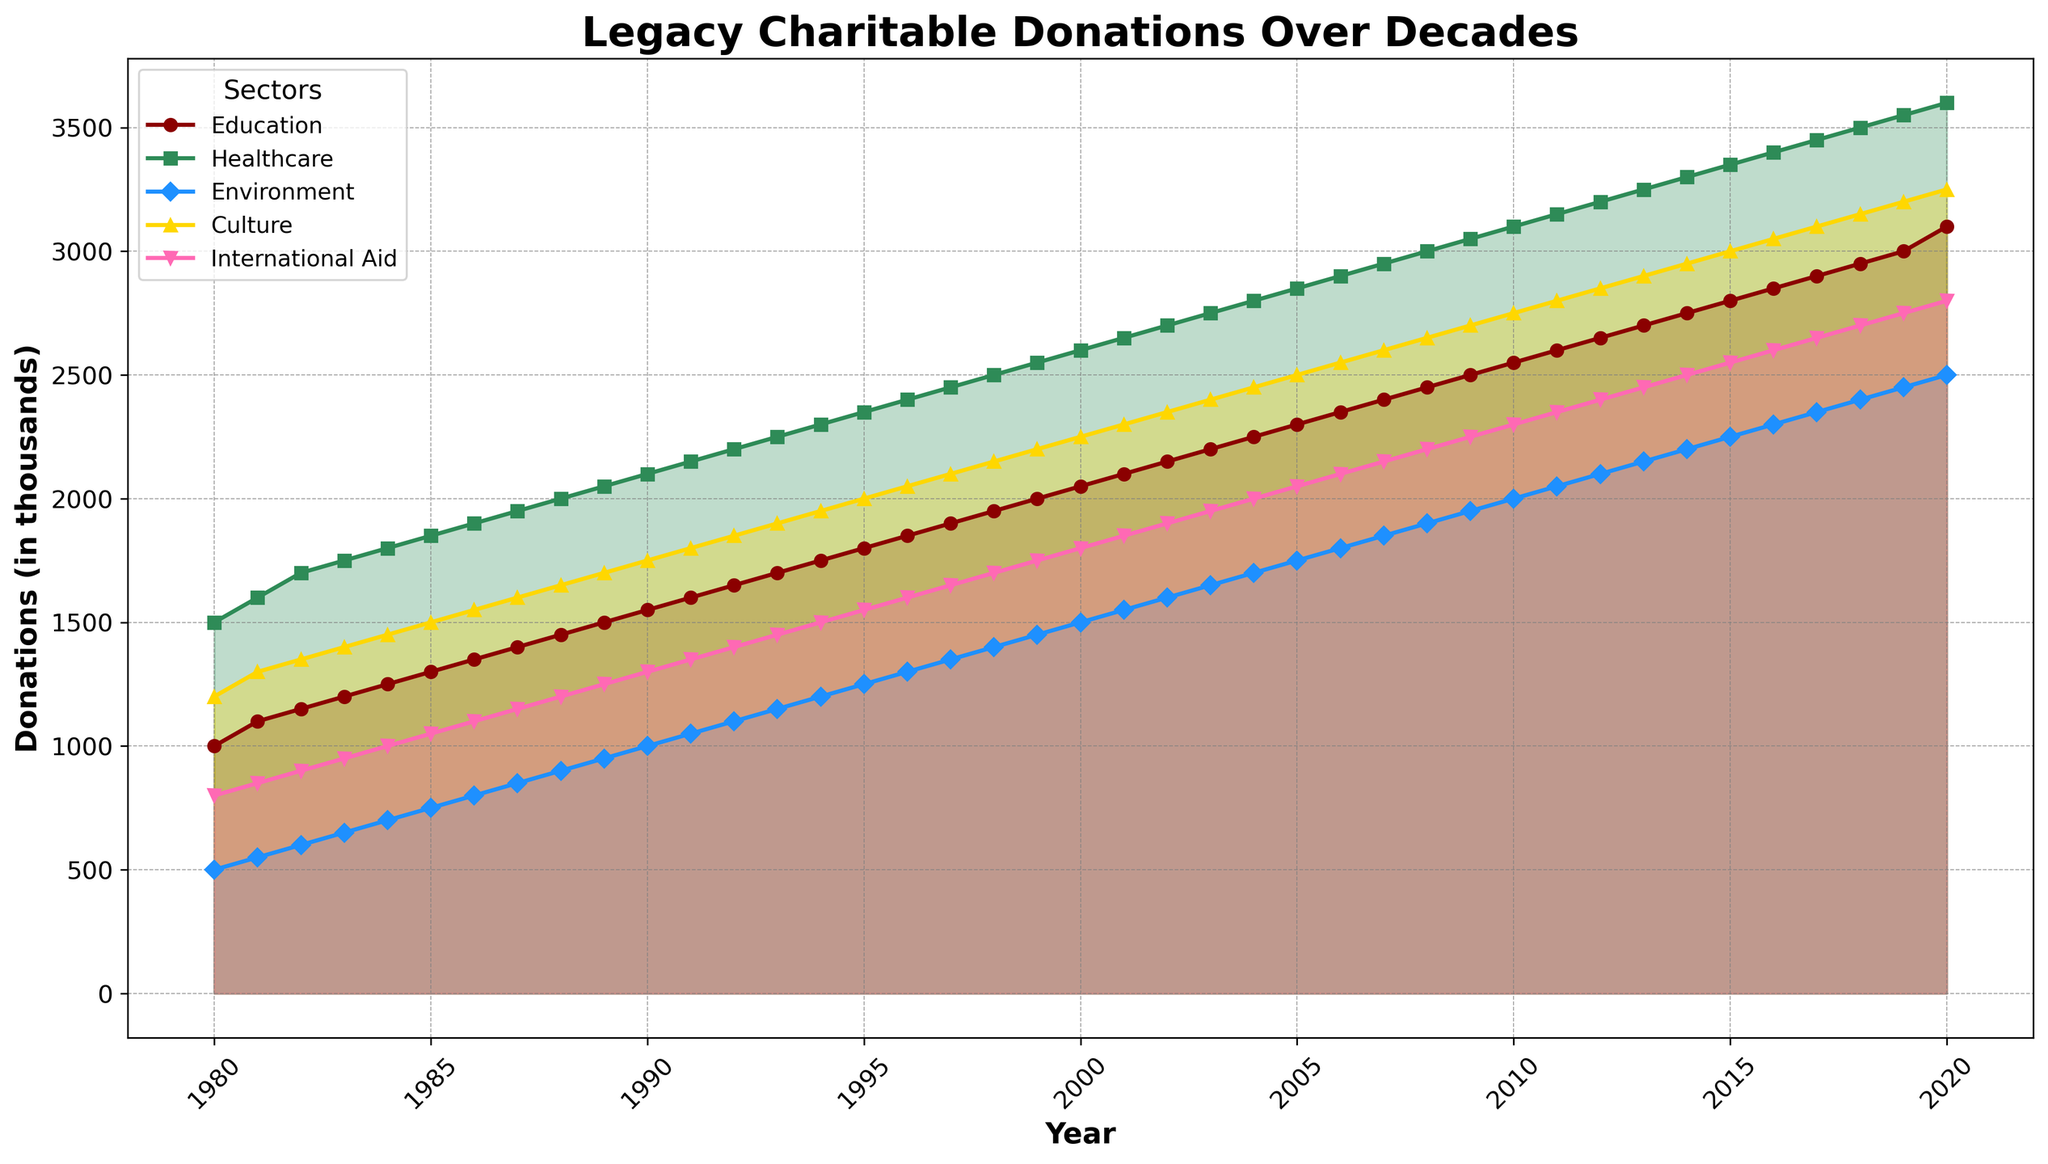What sector had the highest legacy charitable donations in the year 2000? The plot shows different sectors over the years. Locate the year 2000 on the x-axis and look for the highest point among the plotted lines. The Healthcare sector shows the highest value in 2000.
Answer: Healthcare Which sector saw the most consistent growth in donations over the decades? Observe the slopes of the lines for each sector from 1980 to 2020. The Education sector shows a consistent upward trend without significant fluctuations.
Answer: Education In what year did Environment donations surpass 2000 thousand units? Find the line for Environment and locate the year where it crosses the 2000 mark on the y-axis. The Environment sector surpasses 2000 units in the year 2018.
Answer: 2018 Compare the growth of Healthcare donations to Culture donations from 1980 to 2000. Which grew more? Calculate the difference for both sectors between these years. Healthcare grew from 1500 to 2600 (1100 units), while Culture grew from 1200 to 2250 (1050 units). Thus, Healthcare had a greater growth.
Answer: Healthcare What is the cumulative donation value for all sectors in the year 1995? Sum the donation values of all sectors for the year 1995. This means adding the values of Education, Healthcare, Environment, Culture, and International Aid for 1995 (1800 + 2350 + 1250 + 2000 + 1550). The cumulative value is 8950.
Answer: 8950 Which sector had the smallest increase in donations from 1980 to 2020? Calculate the differences for each sector between 1980 to 2020. Education increased by 2100 units, Healthcare by 2100 units, Environment by 2000 units, Culture by 2050 units, and International Aid by 2000 units. The smallest increase is seen in Environment and International Aid.
Answer: Environment and International Aid Identify the sector with the highest donations in 2010 and compare it to the sector with the lowest donations. Find the highest and lowest points in 2010 among all sectors. In 2010, Healthcare is highest with 3100 and Environment is lowest with 2000. The difference is 1100 units.
Answer: Healthcare and Environment What year witnessed the highest growth rate in donations for International Aid compared to the previous year? Look for the steepest upward slope for the International Aid line year-over-year. The steepest segment is between 2019 and 2020.
Answer: 2019-2020 In 1990, by how much did Healthcare donations exceed International Aid donations? Find the donation values for both sectors in 1990 from the plot. Healthcare's value is 2100, and International Aid's is 1300. The difference is 800 units.
Answer: 800 